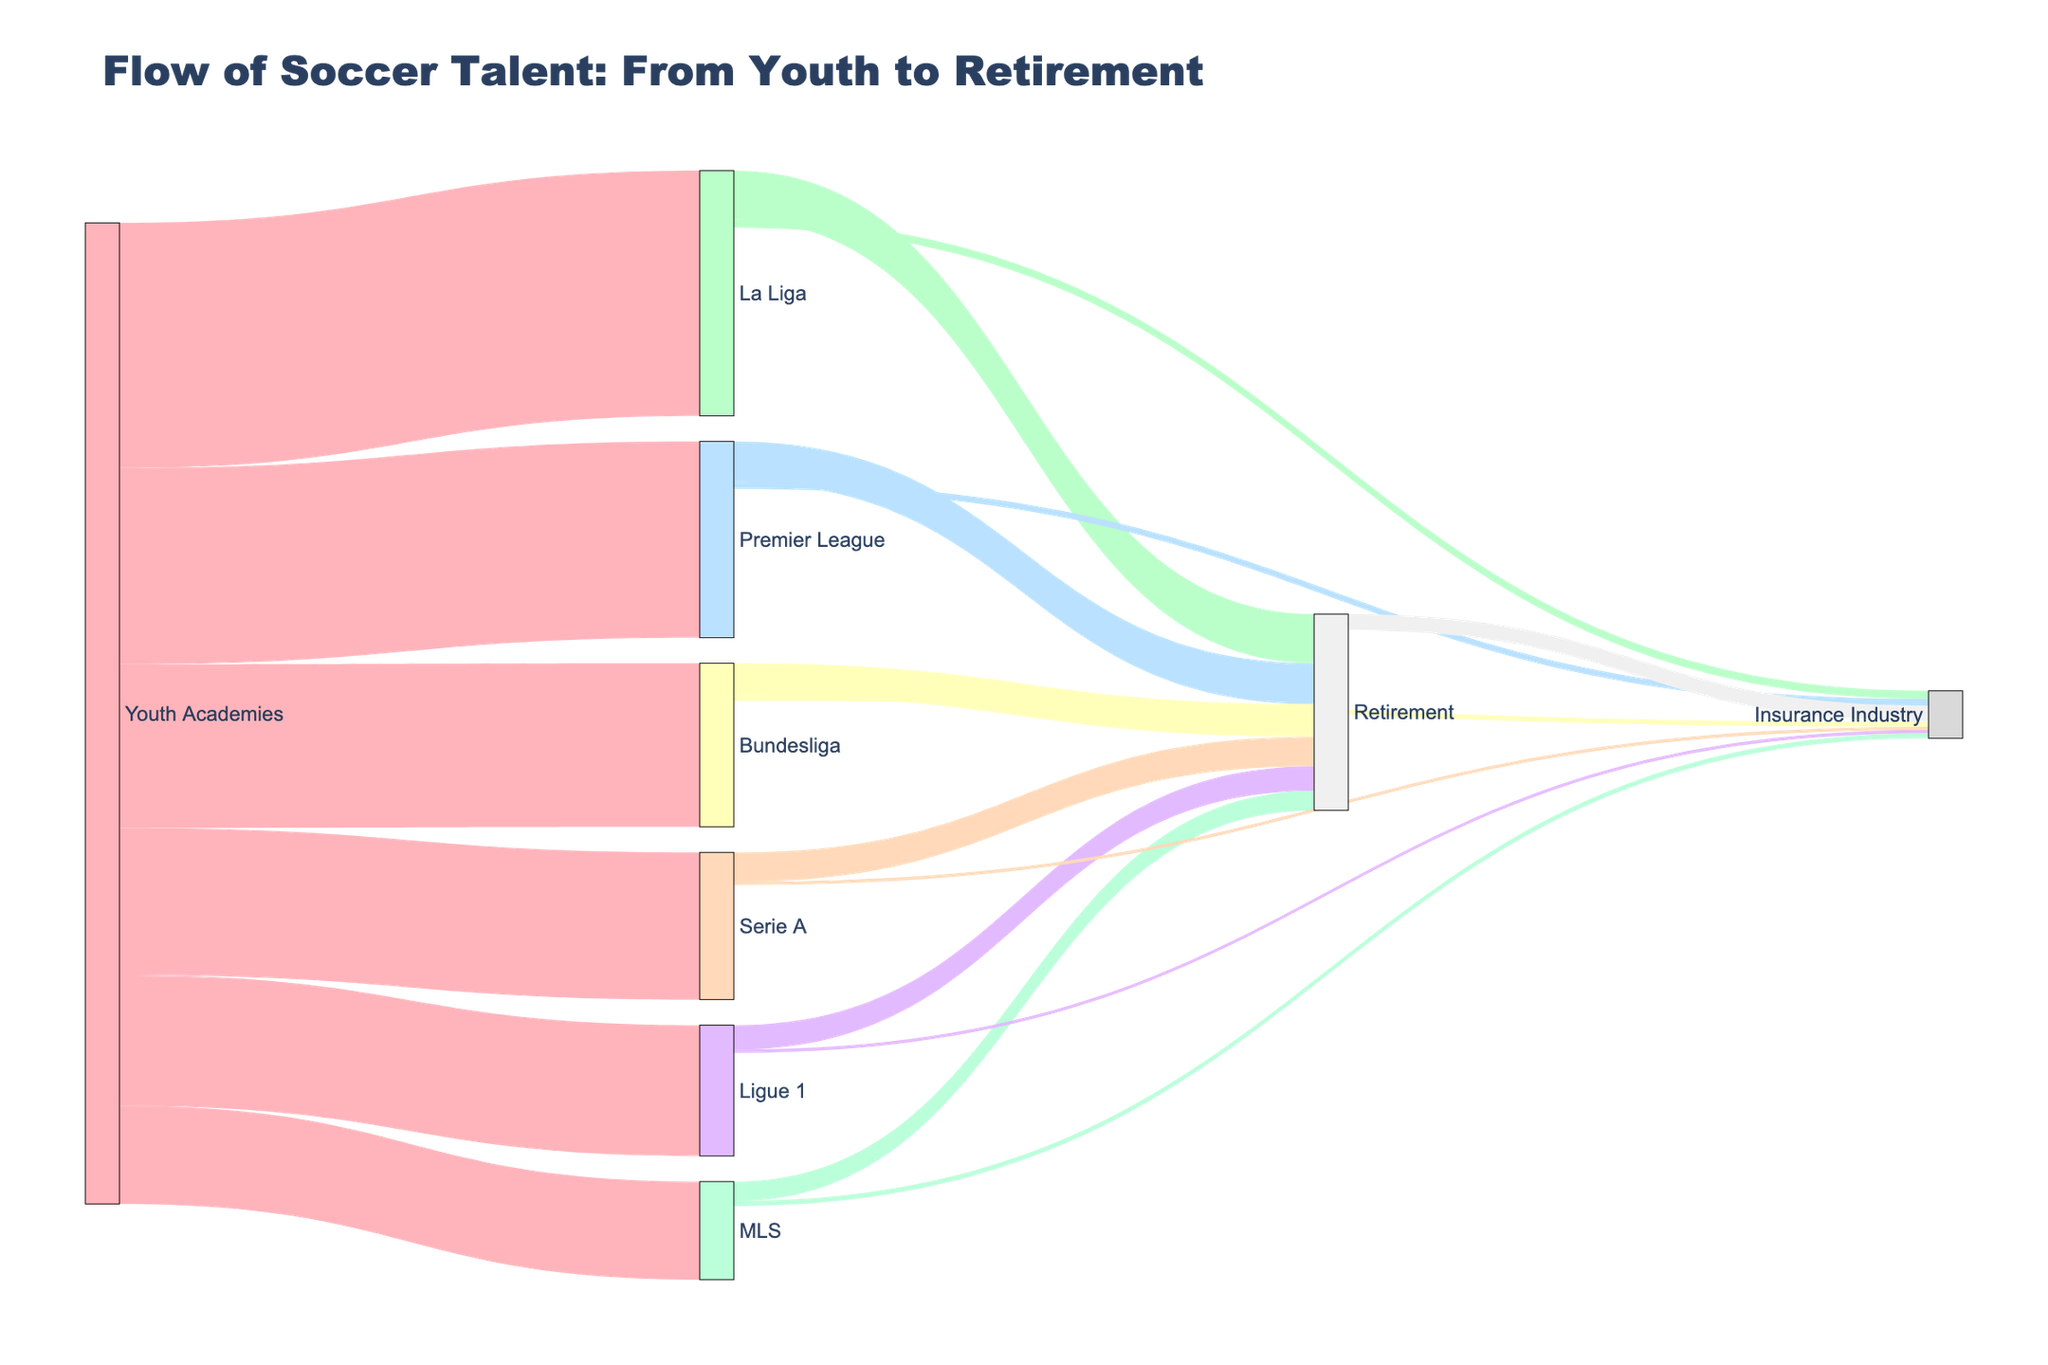Which academy sends the most talent to professional leagues? By examining the width and labels of the flows from the Youth Academies to professional leagues, we see that La Liga has the largest number of players, with a value of 150.
Answer: La Liga How many players move from Youth Academies to Bundesliga? From the data presented on the figure, the flow between Youth Academies and Bundesliga is represented by a link or bar, which shows a value of 100.
Answer: 100 Compare the number of players retiring from La Liga and Ligue 1. Which league has fewer retirees? By comparing the flows from La Liga to Retirement and Ligue 1 to Retirement, it is clear that 30 players retire from La Liga while 15 retire from Ligue 1. Therefore, Ligue 1 has fewer retirees.
Answer: Ligue 1 How many players went from professional leagues to the insurance industry directly? Adding up the values of the flows from each of the professional leagues (La Liga, Premier League, Bundesliga, Serie A, Ligue 1, and MLS) to the Insurance Industry: 5 + 4 + 3 + 2 + 2 + 3 = 19.
Answer: 19 What is the total number of players who transitioned from professional leagues to Retirement? Summing the values of the flows from the professional leagues to Retirement: 30 + 25 + 20 + 18 + 15 + 12 = 120.
Answer: 120 Which professional league shows the smallest transition flow directly to the insurance industry? By examining the data, Serie A and Ligue 1 both have the smallest flow directly to the Insurance Industry, each with a value of 2.
Answer: Serie A and Ligue 1 What is the sum of players who move to the Insurance Industry after Retirement and from Retirement directly? The value for players moving from Retirement directly to the Insurance Industry is 10. Adding this to the sum of players mentioned in question 4: 19 + 10 = 29.
Answer: 29 Which path shows the smallest transition flow overall? The smallest single flow in the diagram is from Serie A to the Insurance Industry, represented by a value of 2 (tied with the flow from Ligue 1 to the Insurance Industry).
Answer: Serie A to Insurance Industry / Ligue 1 to Insurance Industry 